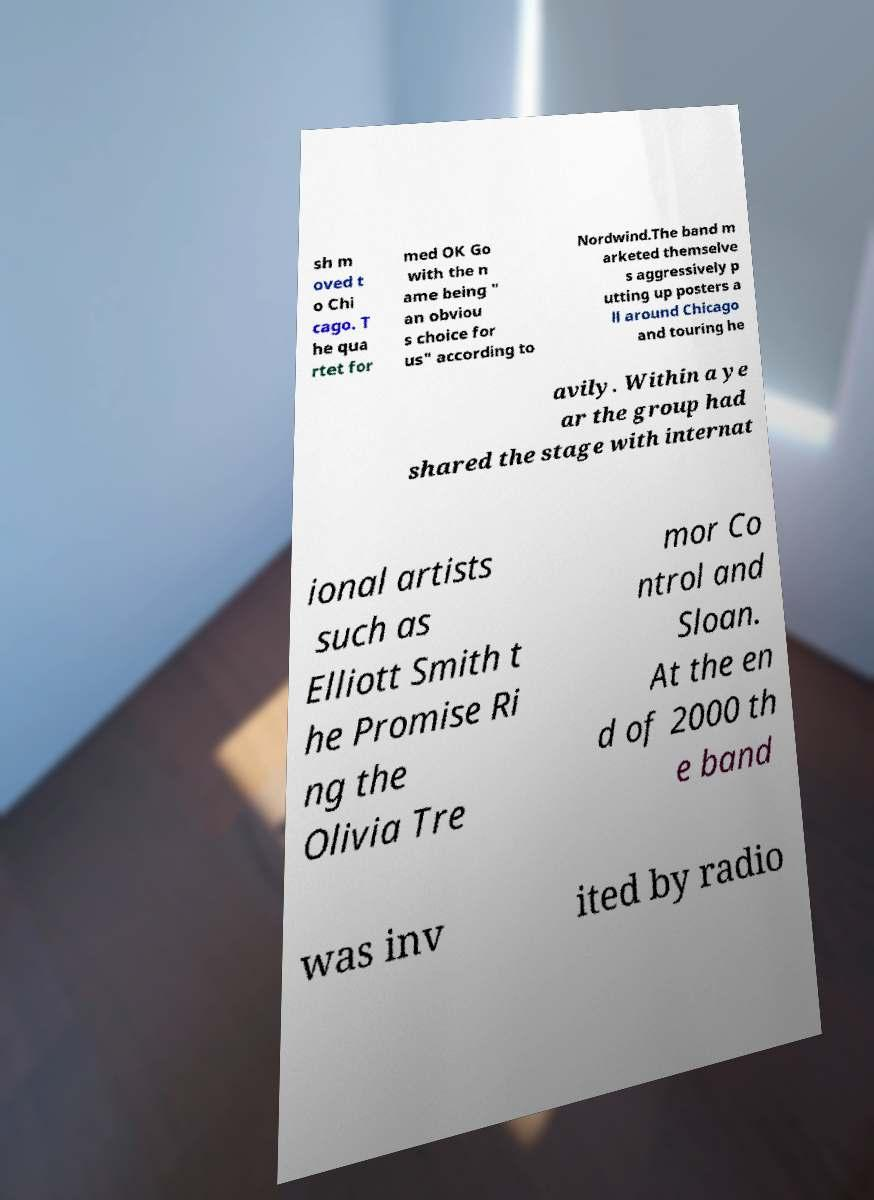Please identify and transcribe the text found in this image. sh m oved t o Chi cago. T he qua rtet for med OK Go with the n ame being " an obviou s choice for us" according to Nordwind.The band m arketed themselve s aggressively p utting up posters a ll around Chicago and touring he avily. Within a ye ar the group had shared the stage with internat ional artists such as Elliott Smith t he Promise Ri ng the Olivia Tre mor Co ntrol and Sloan. At the en d of 2000 th e band was inv ited by radio 